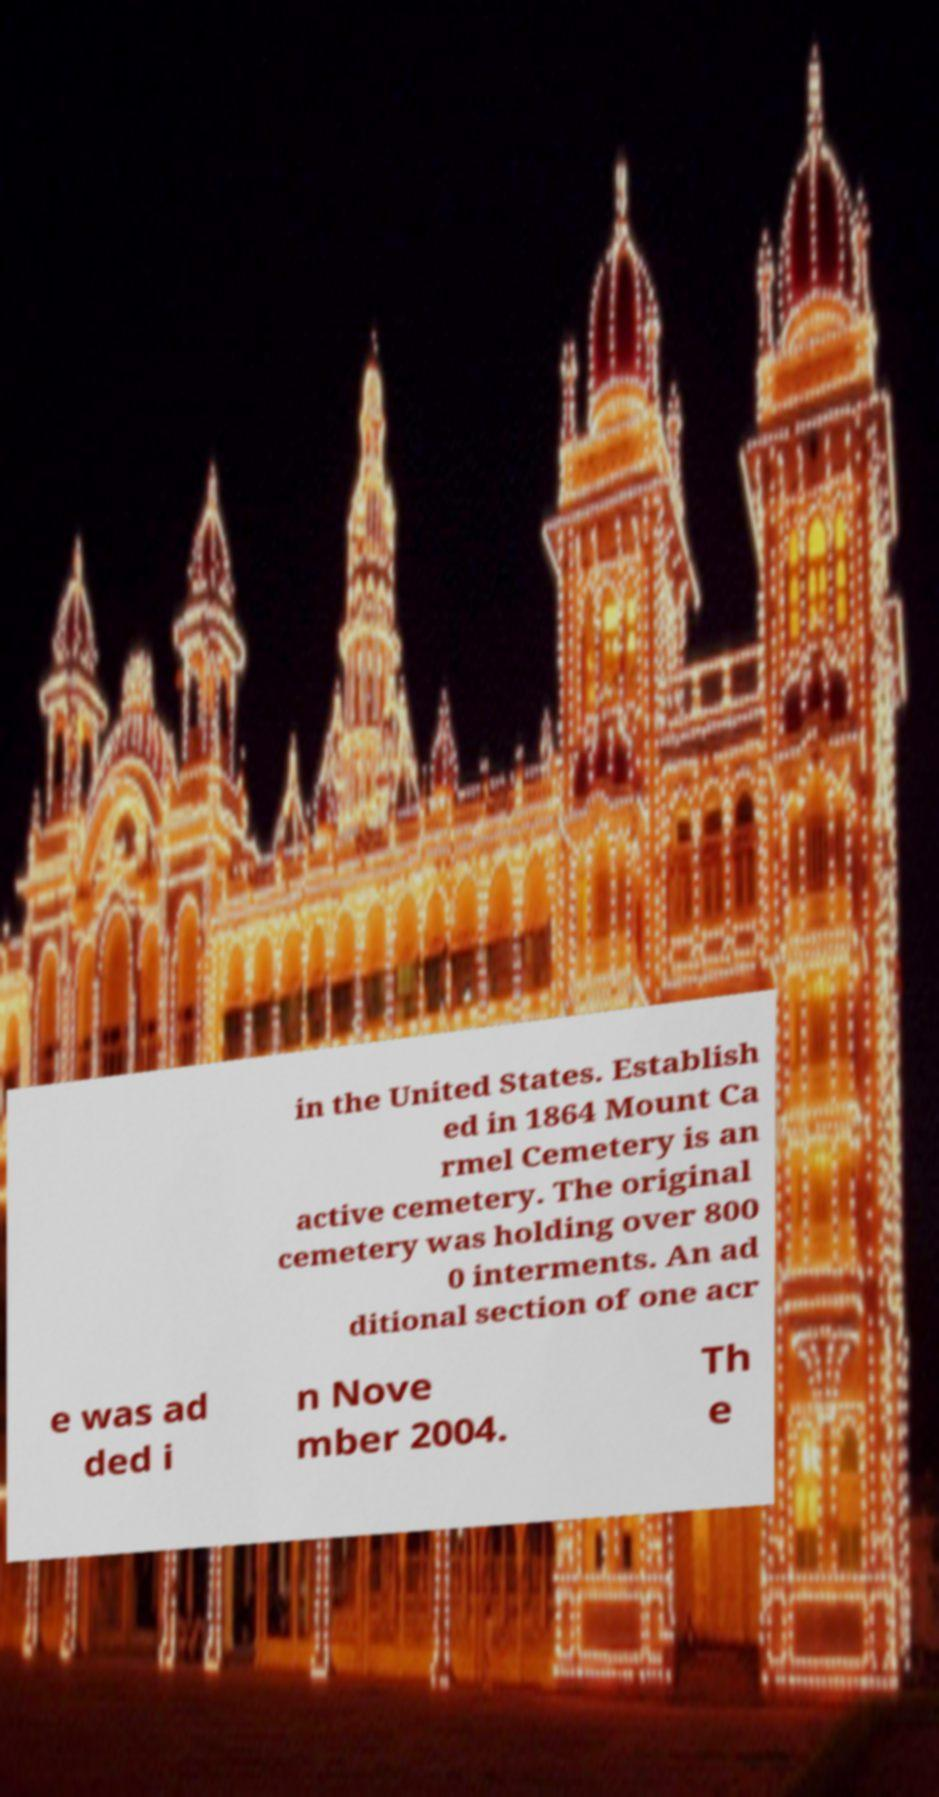What messages or text are displayed in this image? I need them in a readable, typed format. in the United States. Establish ed in 1864 Mount Ca rmel Cemetery is an active cemetery. The original cemetery was holding over 800 0 interments. An ad ditional section of one acr e was ad ded i n Nove mber 2004. Th e 